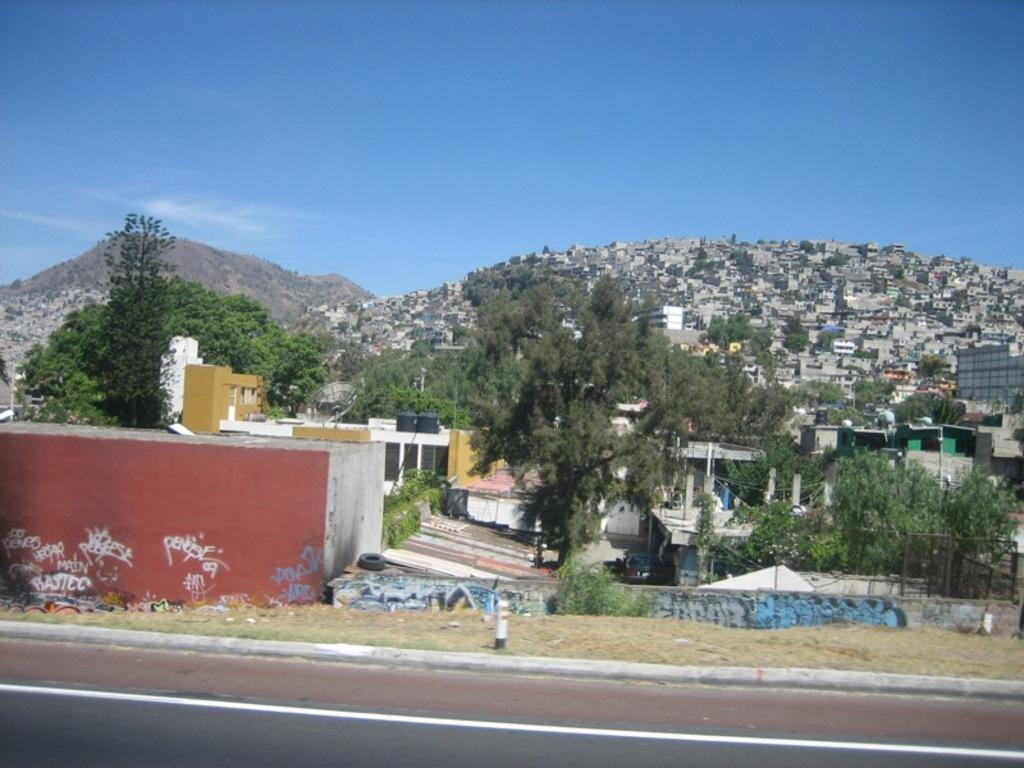What can be seen in the sky in the image? The sky with clouds is visible in the image. What type of natural features are present in the image? There are hills and trees in the image. What type of man-made structures can be seen in the image? Buildings and sheds are visible in the image. What type of pathway is present in the image? A road is present in the image. How many rabbits can be seen playing in the society depicted in the image? There are no rabbits or society depicted in the image; it features natural and man-made elements such as hills, trees, buildings, and sheds. Is there a fire visible in the image? There is no fire present in the image. 